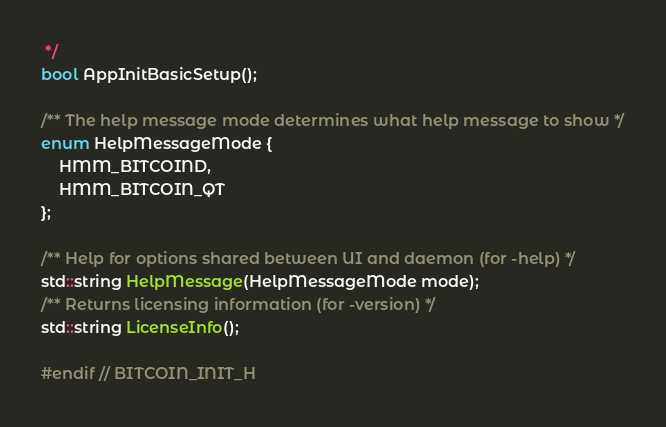Convert code to text. <code><loc_0><loc_0><loc_500><loc_500><_C_> */
bool AppInitBasicSetup();

/** The help message mode determines what help message to show */
enum HelpMessageMode {
    HMM_BITCOIND,
    HMM_BITCOIN_QT
};

/** Help for options shared between UI and daemon (for -help) */
std::string HelpMessage(HelpMessageMode mode);
/** Returns licensing information (for -version) */
std::string LicenseInfo();

#endif // BITCOIN_INIT_H
</code> 